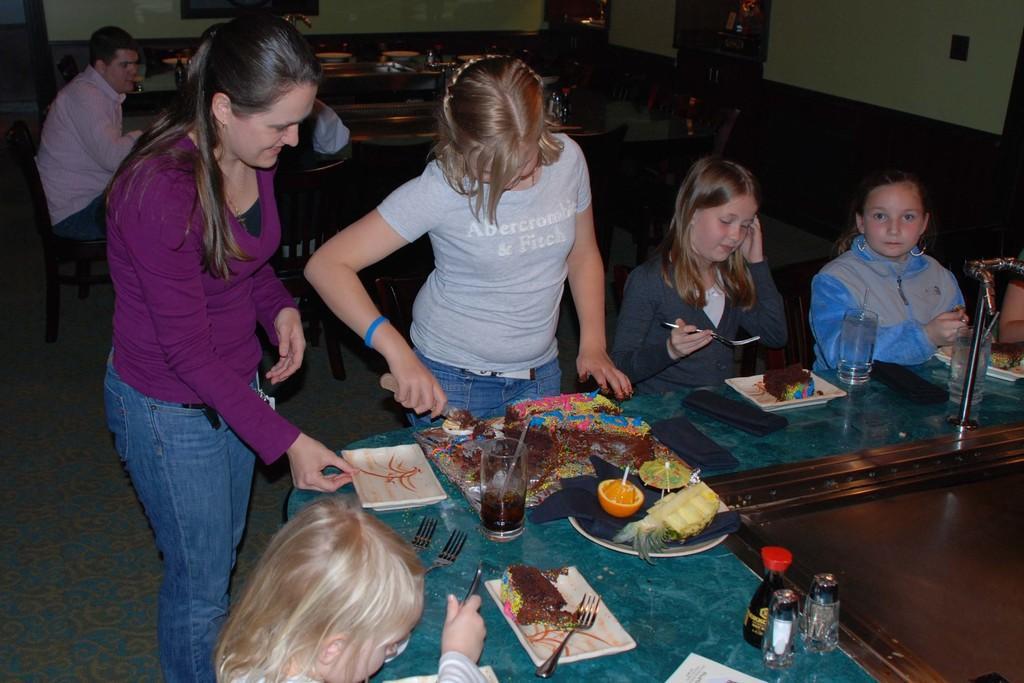How would you summarize this image in a sentence or two? In this picture we can see some people are sitting and some people are standing in front of them there is a table on the table we have some glasses plates bottles And cake and some fruits phones at the backside there are some tables and few people are sitting at the back 